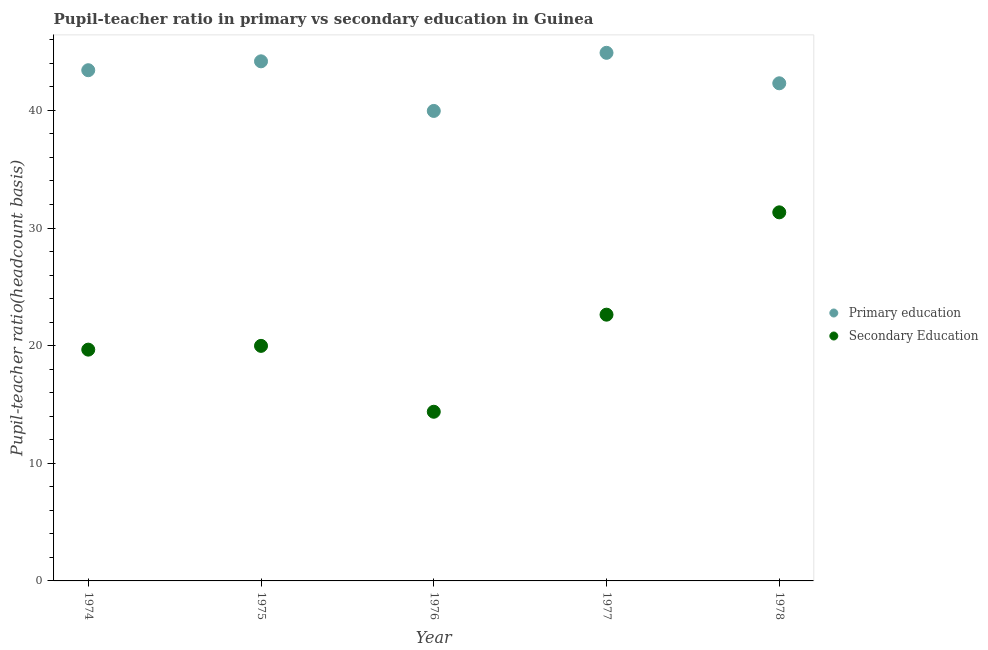Is the number of dotlines equal to the number of legend labels?
Make the answer very short. Yes. What is the pupil-teacher ratio in primary education in 1978?
Give a very brief answer. 42.3. Across all years, what is the maximum pupil teacher ratio on secondary education?
Make the answer very short. 31.33. Across all years, what is the minimum pupil teacher ratio on secondary education?
Ensure brevity in your answer.  14.38. In which year was the pupil teacher ratio on secondary education minimum?
Make the answer very short. 1976. What is the total pupil teacher ratio on secondary education in the graph?
Your response must be concise. 107.99. What is the difference between the pupil-teacher ratio in primary education in 1974 and that in 1976?
Your response must be concise. 3.46. What is the difference between the pupil-teacher ratio in primary education in 1975 and the pupil teacher ratio on secondary education in 1976?
Keep it short and to the point. 29.79. What is the average pupil-teacher ratio in primary education per year?
Give a very brief answer. 42.95. In the year 1974, what is the difference between the pupil-teacher ratio in primary education and pupil teacher ratio on secondary education?
Keep it short and to the point. 23.75. What is the ratio of the pupil teacher ratio on secondary education in 1976 to that in 1977?
Offer a terse response. 0.64. Is the pupil teacher ratio on secondary education in 1974 less than that in 1978?
Offer a very short reply. Yes. Is the difference between the pupil-teacher ratio in primary education in 1976 and 1977 greater than the difference between the pupil teacher ratio on secondary education in 1976 and 1977?
Your answer should be very brief. Yes. What is the difference between the highest and the second highest pupil-teacher ratio in primary education?
Your response must be concise. 0.72. What is the difference between the highest and the lowest pupil-teacher ratio in primary education?
Provide a short and direct response. 4.94. In how many years, is the pupil-teacher ratio in primary education greater than the average pupil-teacher ratio in primary education taken over all years?
Your response must be concise. 3. Is the sum of the pupil teacher ratio on secondary education in 1974 and 1978 greater than the maximum pupil-teacher ratio in primary education across all years?
Make the answer very short. Yes. Is the pupil teacher ratio on secondary education strictly less than the pupil-teacher ratio in primary education over the years?
Offer a terse response. Yes. How many years are there in the graph?
Offer a terse response. 5. Does the graph contain any zero values?
Your response must be concise. No. Does the graph contain grids?
Keep it short and to the point. No. Where does the legend appear in the graph?
Your answer should be very brief. Center right. How are the legend labels stacked?
Give a very brief answer. Vertical. What is the title of the graph?
Give a very brief answer. Pupil-teacher ratio in primary vs secondary education in Guinea. What is the label or title of the Y-axis?
Your response must be concise. Pupil-teacher ratio(headcount basis). What is the Pupil-teacher ratio(headcount basis) in Primary education in 1974?
Give a very brief answer. 43.42. What is the Pupil-teacher ratio(headcount basis) in Secondary Education in 1974?
Your answer should be very brief. 19.66. What is the Pupil-teacher ratio(headcount basis) in Primary education in 1975?
Provide a short and direct response. 44.17. What is the Pupil-teacher ratio(headcount basis) of Secondary Education in 1975?
Ensure brevity in your answer.  19.98. What is the Pupil-teacher ratio(headcount basis) of Primary education in 1976?
Your answer should be compact. 39.95. What is the Pupil-teacher ratio(headcount basis) in Secondary Education in 1976?
Your answer should be very brief. 14.38. What is the Pupil-teacher ratio(headcount basis) in Primary education in 1977?
Give a very brief answer. 44.89. What is the Pupil-teacher ratio(headcount basis) in Secondary Education in 1977?
Make the answer very short. 22.63. What is the Pupil-teacher ratio(headcount basis) in Primary education in 1978?
Offer a terse response. 42.3. What is the Pupil-teacher ratio(headcount basis) in Secondary Education in 1978?
Make the answer very short. 31.33. Across all years, what is the maximum Pupil-teacher ratio(headcount basis) in Primary education?
Ensure brevity in your answer.  44.89. Across all years, what is the maximum Pupil-teacher ratio(headcount basis) of Secondary Education?
Offer a very short reply. 31.33. Across all years, what is the minimum Pupil-teacher ratio(headcount basis) of Primary education?
Your response must be concise. 39.95. Across all years, what is the minimum Pupil-teacher ratio(headcount basis) in Secondary Education?
Make the answer very short. 14.38. What is the total Pupil-teacher ratio(headcount basis) in Primary education in the graph?
Give a very brief answer. 214.74. What is the total Pupil-teacher ratio(headcount basis) in Secondary Education in the graph?
Your answer should be compact. 107.99. What is the difference between the Pupil-teacher ratio(headcount basis) of Primary education in 1974 and that in 1975?
Offer a very short reply. -0.76. What is the difference between the Pupil-teacher ratio(headcount basis) of Secondary Education in 1974 and that in 1975?
Give a very brief answer. -0.32. What is the difference between the Pupil-teacher ratio(headcount basis) in Primary education in 1974 and that in 1976?
Ensure brevity in your answer.  3.46. What is the difference between the Pupil-teacher ratio(headcount basis) of Secondary Education in 1974 and that in 1976?
Your response must be concise. 5.28. What is the difference between the Pupil-teacher ratio(headcount basis) of Primary education in 1974 and that in 1977?
Provide a succinct answer. -1.48. What is the difference between the Pupil-teacher ratio(headcount basis) in Secondary Education in 1974 and that in 1977?
Offer a very short reply. -2.97. What is the difference between the Pupil-teacher ratio(headcount basis) of Primary education in 1974 and that in 1978?
Your answer should be compact. 1.11. What is the difference between the Pupil-teacher ratio(headcount basis) in Secondary Education in 1974 and that in 1978?
Your answer should be very brief. -11.67. What is the difference between the Pupil-teacher ratio(headcount basis) of Primary education in 1975 and that in 1976?
Keep it short and to the point. 4.22. What is the difference between the Pupil-teacher ratio(headcount basis) in Secondary Education in 1975 and that in 1976?
Offer a terse response. 5.6. What is the difference between the Pupil-teacher ratio(headcount basis) of Primary education in 1975 and that in 1977?
Keep it short and to the point. -0.72. What is the difference between the Pupil-teacher ratio(headcount basis) in Secondary Education in 1975 and that in 1977?
Give a very brief answer. -2.65. What is the difference between the Pupil-teacher ratio(headcount basis) of Primary education in 1975 and that in 1978?
Give a very brief answer. 1.87. What is the difference between the Pupil-teacher ratio(headcount basis) in Secondary Education in 1975 and that in 1978?
Ensure brevity in your answer.  -11.35. What is the difference between the Pupil-teacher ratio(headcount basis) in Primary education in 1976 and that in 1977?
Ensure brevity in your answer.  -4.94. What is the difference between the Pupil-teacher ratio(headcount basis) of Secondary Education in 1976 and that in 1977?
Make the answer very short. -8.25. What is the difference between the Pupil-teacher ratio(headcount basis) of Primary education in 1976 and that in 1978?
Offer a very short reply. -2.35. What is the difference between the Pupil-teacher ratio(headcount basis) of Secondary Education in 1976 and that in 1978?
Your answer should be compact. -16.95. What is the difference between the Pupil-teacher ratio(headcount basis) of Primary education in 1977 and that in 1978?
Give a very brief answer. 2.59. What is the difference between the Pupil-teacher ratio(headcount basis) of Secondary Education in 1977 and that in 1978?
Your answer should be very brief. -8.7. What is the difference between the Pupil-teacher ratio(headcount basis) of Primary education in 1974 and the Pupil-teacher ratio(headcount basis) of Secondary Education in 1975?
Offer a very short reply. 23.43. What is the difference between the Pupil-teacher ratio(headcount basis) in Primary education in 1974 and the Pupil-teacher ratio(headcount basis) in Secondary Education in 1976?
Offer a very short reply. 29.03. What is the difference between the Pupil-teacher ratio(headcount basis) in Primary education in 1974 and the Pupil-teacher ratio(headcount basis) in Secondary Education in 1977?
Your answer should be compact. 20.78. What is the difference between the Pupil-teacher ratio(headcount basis) of Primary education in 1974 and the Pupil-teacher ratio(headcount basis) of Secondary Education in 1978?
Offer a terse response. 12.08. What is the difference between the Pupil-teacher ratio(headcount basis) in Primary education in 1975 and the Pupil-teacher ratio(headcount basis) in Secondary Education in 1976?
Your answer should be compact. 29.79. What is the difference between the Pupil-teacher ratio(headcount basis) in Primary education in 1975 and the Pupil-teacher ratio(headcount basis) in Secondary Education in 1977?
Ensure brevity in your answer.  21.54. What is the difference between the Pupil-teacher ratio(headcount basis) of Primary education in 1975 and the Pupil-teacher ratio(headcount basis) of Secondary Education in 1978?
Provide a succinct answer. 12.84. What is the difference between the Pupil-teacher ratio(headcount basis) in Primary education in 1976 and the Pupil-teacher ratio(headcount basis) in Secondary Education in 1977?
Keep it short and to the point. 17.32. What is the difference between the Pupil-teacher ratio(headcount basis) in Primary education in 1976 and the Pupil-teacher ratio(headcount basis) in Secondary Education in 1978?
Keep it short and to the point. 8.62. What is the difference between the Pupil-teacher ratio(headcount basis) in Primary education in 1977 and the Pupil-teacher ratio(headcount basis) in Secondary Education in 1978?
Your answer should be compact. 13.56. What is the average Pupil-teacher ratio(headcount basis) of Primary education per year?
Your response must be concise. 42.95. What is the average Pupil-teacher ratio(headcount basis) in Secondary Education per year?
Your response must be concise. 21.6. In the year 1974, what is the difference between the Pupil-teacher ratio(headcount basis) of Primary education and Pupil-teacher ratio(headcount basis) of Secondary Education?
Your response must be concise. 23.75. In the year 1975, what is the difference between the Pupil-teacher ratio(headcount basis) of Primary education and Pupil-teacher ratio(headcount basis) of Secondary Education?
Make the answer very short. 24.19. In the year 1976, what is the difference between the Pupil-teacher ratio(headcount basis) in Primary education and Pupil-teacher ratio(headcount basis) in Secondary Education?
Keep it short and to the point. 25.57. In the year 1977, what is the difference between the Pupil-teacher ratio(headcount basis) in Primary education and Pupil-teacher ratio(headcount basis) in Secondary Education?
Your answer should be very brief. 22.26. In the year 1978, what is the difference between the Pupil-teacher ratio(headcount basis) in Primary education and Pupil-teacher ratio(headcount basis) in Secondary Education?
Your response must be concise. 10.97. What is the ratio of the Pupil-teacher ratio(headcount basis) of Primary education in 1974 to that in 1975?
Ensure brevity in your answer.  0.98. What is the ratio of the Pupil-teacher ratio(headcount basis) in Primary education in 1974 to that in 1976?
Offer a terse response. 1.09. What is the ratio of the Pupil-teacher ratio(headcount basis) of Secondary Education in 1974 to that in 1976?
Make the answer very short. 1.37. What is the ratio of the Pupil-teacher ratio(headcount basis) of Primary education in 1974 to that in 1977?
Keep it short and to the point. 0.97. What is the ratio of the Pupil-teacher ratio(headcount basis) of Secondary Education in 1974 to that in 1977?
Your answer should be very brief. 0.87. What is the ratio of the Pupil-teacher ratio(headcount basis) of Primary education in 1974 to that in 1978?
Provide a succinct answer. 1.03. What is the ratio of the Pupil-teacher ratio(headcount basis) of Secondary Education in 1974 to that in 1978?
Provide a short and direct response. 0.63. What is the ratio of the Pupil-teacher ratio(headcount basis) of Primary education in 1975 to that in 1976?
Offer a very short reply. 1.11. What is the ratio of the Pupil-teacher ratio(headcount basis) of Secondary Education in 1975 to that in 1976?
Provide a short and direct response. 1.39. What is the ratio of the Pupil-teacher ratio(headcount basis) in Primary education in 1975 to that in 1977?
Provide a short and direct response. 0.98. What is the ratio of the Pupil-teacher ratio(headcount basis) of Secondary Education in 1975 to that in 1977?
Your answer should be very brief. 0.88. What is the ratio of the Pupil-teacher ratio(headcount basis) of Primary education in 1975 to that in 1978?
Provide a short and direct response. 1.04. What is the ratio of the Pupil-teacher ratio(headcount basis) of Secondary Education in 1975 to that in 1978?
Give a very brief answer. 0.64. What is the ratio of the Pupil-teacher ratio(headcount basis) of Primary education in 1976 to that in 1977?
Keep it short and to the point. 0.89. What is the ratio of the Pupil-teacher ratio(headcount basis) in Secondary Education in 1976 to that in 1977?
Ensure brevity in your answer.  0.64. What is the ratio of the Pupil-teacher ratio(headcount basis) in Primary education in 1976 to that in 1978?
Your answer should be very brief. 0.94. What is the ratio of the Pupil-teacher ratio(headcount basis) of Secondary Education in 1976 to that in 1978?
Ensure brevity in your answer.  0.46. What is the ratio of the Pupil-teacher ratio(headcount basis) of Primary education in 1977 to that in 1978?
Offer a terse response. 1.06. What is the ratio of the Pupil-teacher ratio(headcount basis) of Secondary Education in 1977 to that in 1978?
Your answer should be very brief. 0.72. What is the difference between the highest and the second highest Pupil-teacher ratio(headcount basis) in Primary education?
Offer a very short reply. 0.72. What is the difference between the highest and the second highest Pupil-teacher ratio(headcount basis) of Secondary Education?
Ensure brevity in your answer.  8.7. What is the difference between the highest and the lowest Pupil-teacher ratio(headcount basis) in Primary education?
Your answer should be compact. 4.94. What is the difference between the highest and the lowest Pupil-teacher ratio(headcount basis) in Secondary Education?
Keep it short and to the point. 16.95. 